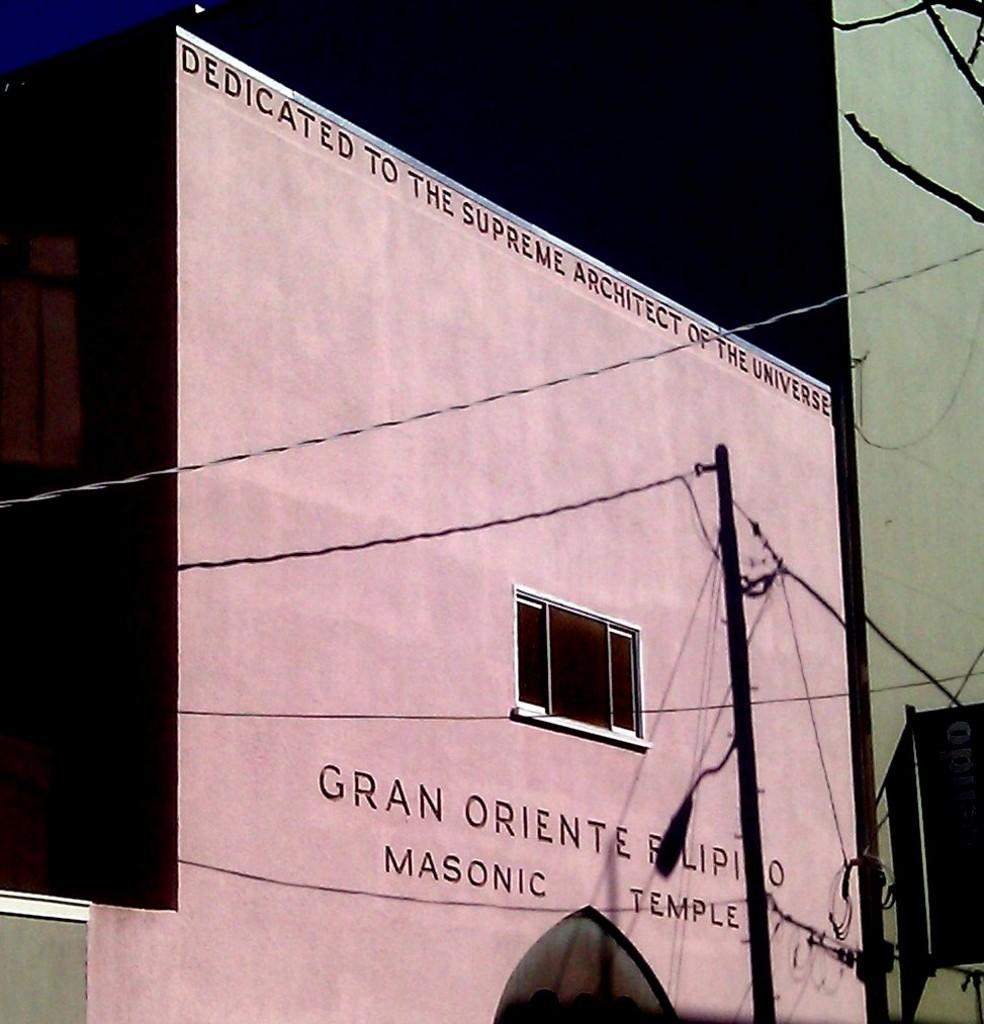Describe this image in one or two sentences. In the picture I can see a building which has a window and something written on it. I can also see a pole, wires and some other things. This is a cartoon image. 